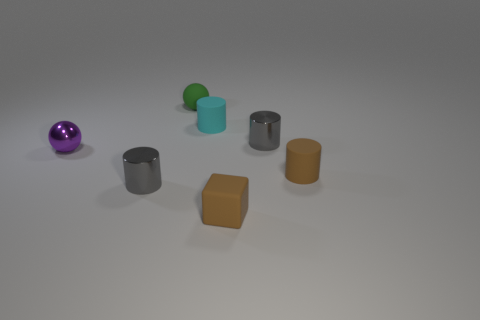Subtract 1 cylinders. How many cylinders are left? 3 Add 2 tiny cyan cylinders. How many objects exist? 9 Subtract all blocks. How many objects are left? 6 Subtract 0 purple cylinders. How many objects are left? 7 Subtract all tiny green metallic balls. Subtract all purple objects. How many objects are left? 6 Add 5 shiny things. How many shiny things are left? 8 Add 6 gray metallic cubes. How many gray metallic cubes exist? 6 